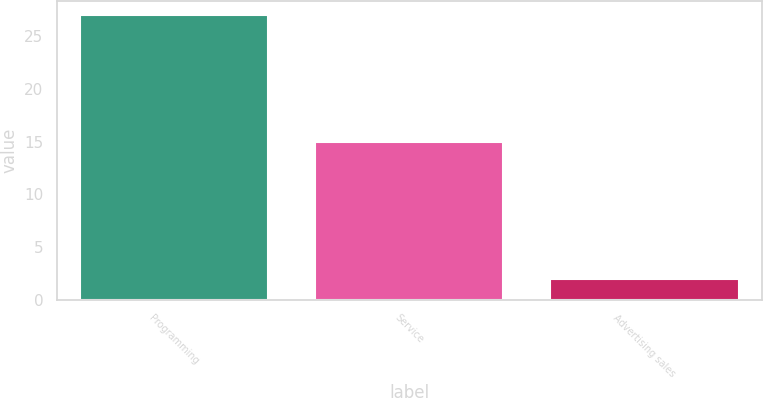Convert chart. <chart><loc_0><loc_0><loc_500><loc_500><bar_chart><fcel>Programming<fcel>Service<fcel>Advertising sales<nl><fcel>27<fcel>15<fcel>2<nl></chart> 